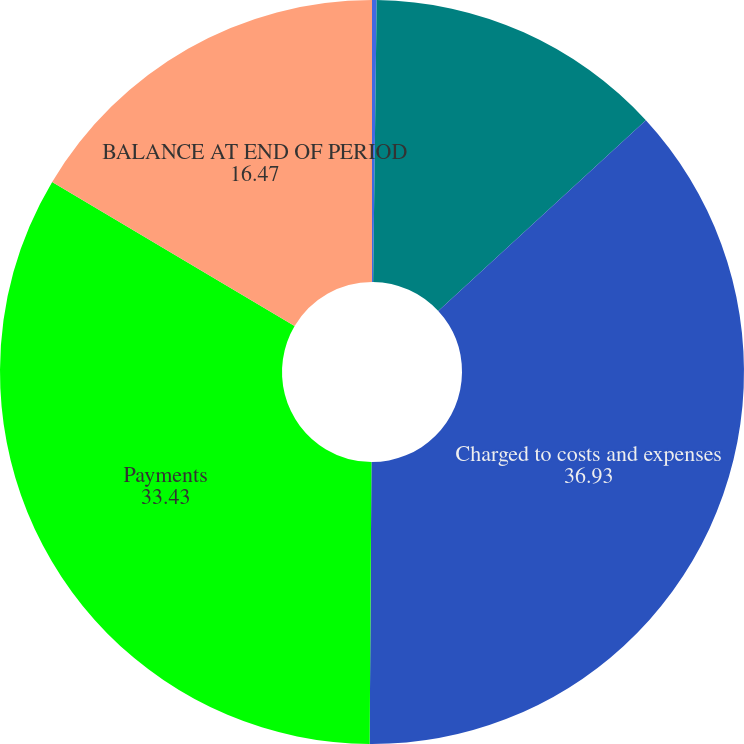<chart> <loc_0><loc_0><loc_500><loc_500><pie_chart><fcel>(In thousands)<fcel>Balance at beginning of period<fcel>Charged to costs and expenses<fcel>Payments<fcel>BALANCE AT END OF PERIOD<nl><fcel>0.2%<fcel>12.97%<fcel>36.93%<fcel>33.43%<fcel>16.47%<nl></chart> 